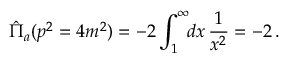Convert formula to latex. <formula><loc_0><loc_0><loc_500><loc_500>\hat { \Pi } _ { a } ( p ^ { 2 } = 4 m ^ { 2 } ) = - 2 \int _ { 1 } ^ { \infty } \, d x \, \frac { 1 } { x ^ { 2 } } = - 2 \, .</formula> 